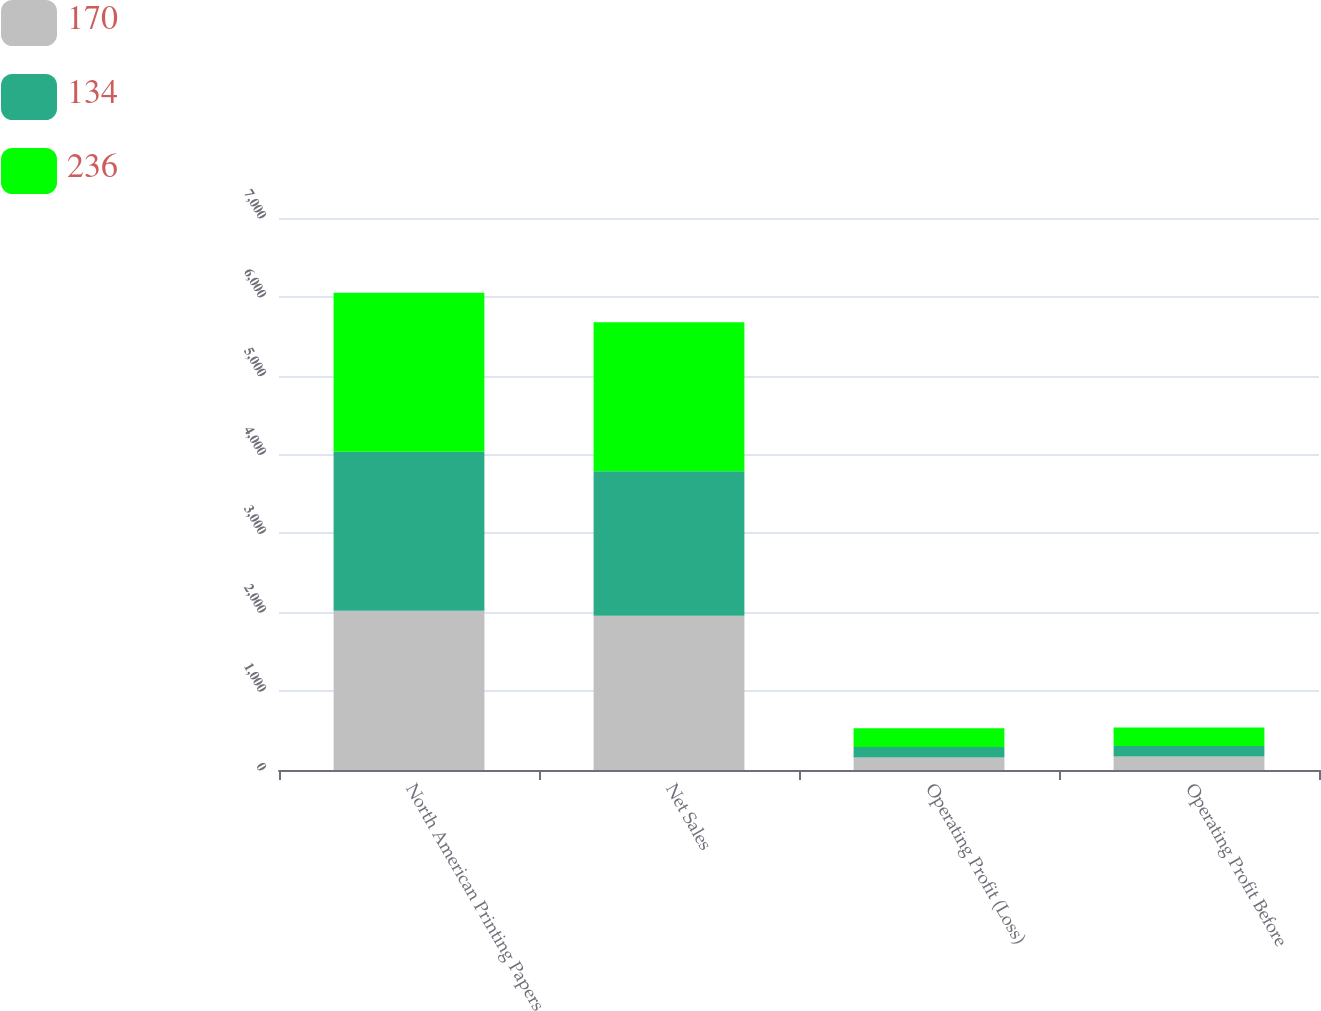Convert chart. <chart><loc_0><loc_0><loc_500><loc_500><stacked_bar_chart><ecel><fcel>North American Printing Papers<fcel>Net Sales<fcel>Operating Profit (Loss)<fcel>Operating Profit Before<nl><fcel>170<fcel>2018<fcel>1956<fcel>160<fcel>170<nl><fcel>134<fcel>2017<fcel>1833<fcel>132<fcel>134<nl><fcel>236<fcel>2016<fcel>1890<fcel>236<fcel>236<nl></chart> 